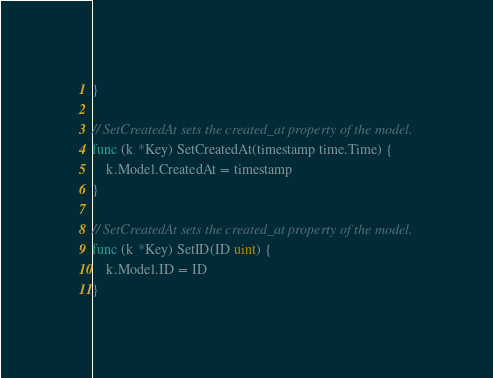Convert code to text. <code><loc_0><loc_0><loc_500><loc_500><_Go_>}

// SetCreatedAt sets the created_at property of the model.
func (k *Key) SetCreatedAt(timestamp time.Time) {
	k.Model.CreatedAt = timestamp
}

// SetCreatedAt sets the created_at property of the model.
func (k *Key) SetID(ID uint) {
	k.Model.ID = ID
}
</code> 